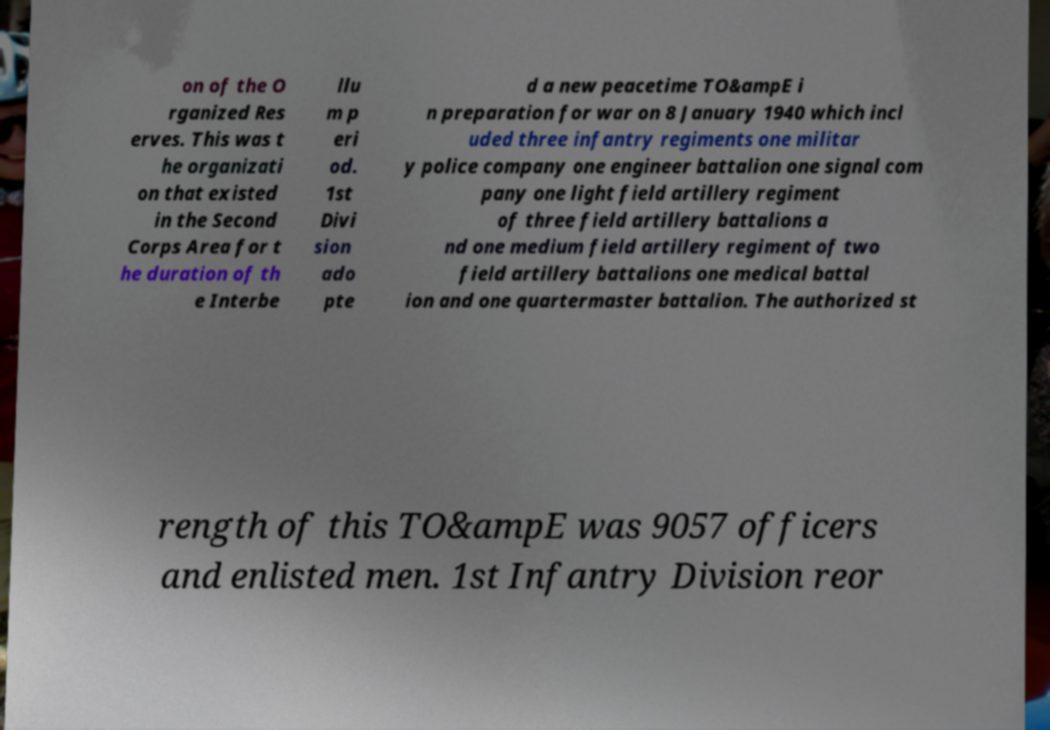Can you read and provide the text displayed in the image?This photo seems to have some interesting text. Can you extract and type it out for me? on of the O rganized Res erves. This was t he organizati on that existed in the Second Corps Area for t he duration of th e Interbe llu m p eri od. 1st Divi sion ado pte d a new peacetime TO&ampE i n preparation for war on 8 January 1940 which incl uded three infantry regiments one militar y police company one engineer battalion one signal com pany one light field artillery regiment of three field artillery battalions a nd one medium field artillery regiment of two field artillery battalions one medical battal ion and one quartermaster battalion. The authorized st rength of this TO&ampE was 9057 officers and enlisted men. 1st Infantry Division reor 